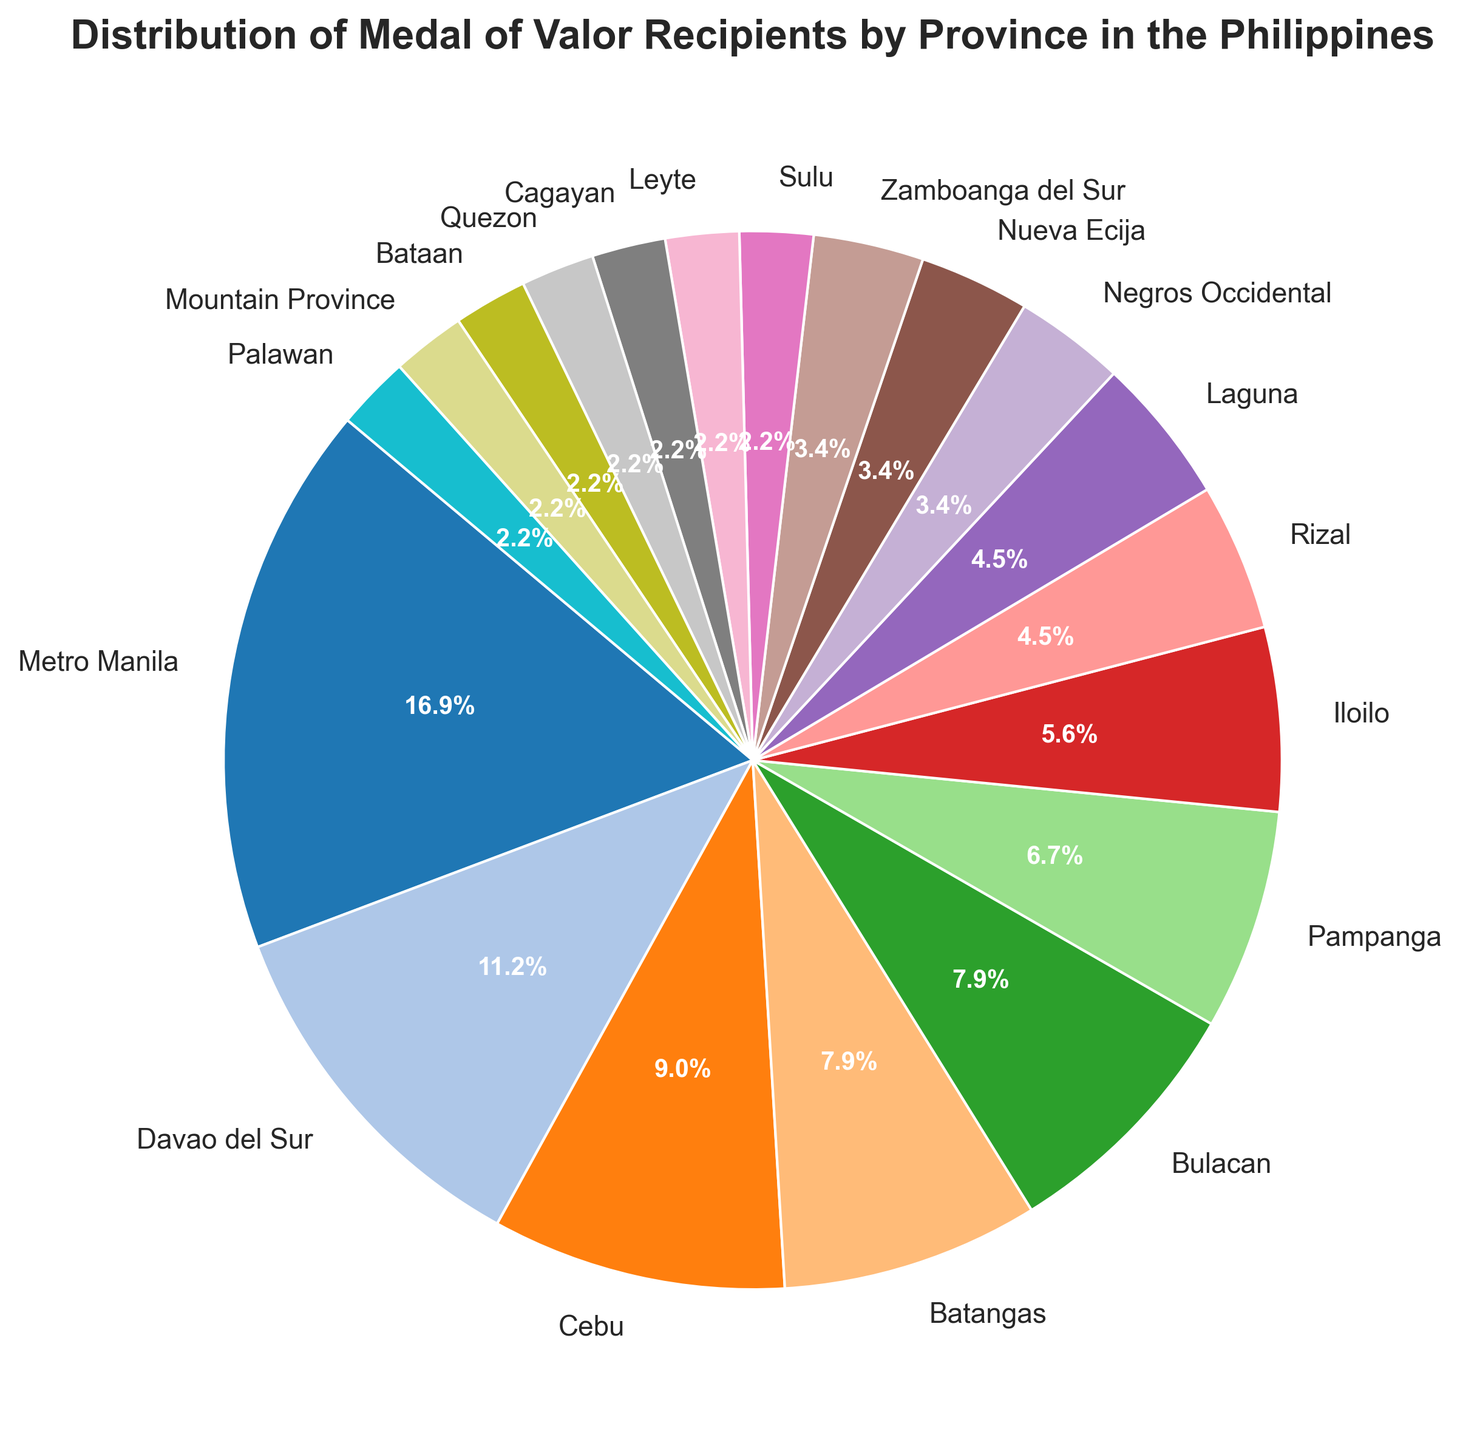Which province has the highest number of Medal of Valor recipients? Metro Manila occupies the largest section of the pie chart, indicating it has the most recipients.
Answer: Metro Manila What percentage of Medal of Valor recipients come from outside Metro Manila? Metro Manila accounts for 15 recipients out of a total of 91 (15 from Metro Manila + 76 from other provinces), therefore the percentage from other provinces is ((76/91) * 100)%.
Answer: Approximately 83.5% Which provinces have the same number of recipients? By examining the chart segments and their labels, Batangas and Bulacan have the same number of recipients, as do Laguna and Rizal.
Answer: Batangas and Bulacan, Laguna and Rizal How many provinces have fewer than 5 recipients? To determine this, identify the slices representing those provinces with fewer than 5 recipients, such as Negros Occidental, Nueva Ecija, Zamboanga del Sur, and others with even fewer. Count these slices.
Answer: 12 provinces What is the combined percentage of recipients from Cebu, Batangas, and Bulacan? Add the recipients from these provinces (8 from Cebu, 7 from Batangas, 7 from Bulacan). The combined total is 22 out of 91. The percentage is (22/91) * 100.
Answer: Approximately 24.2% How does the number of recipients in Pampanga compare to those in Iloilo? Look at the pie chart slices for these provinces. Pampanga has 6 recipients, and Iloilo has 5 recipients. Therefore, Pampanga has more recipients than Iloilo.
Answer: Pampanga has more recipients Which province contributed the smallest number of recipients? The slices representing Sulu, Leyte, Cagayan, Quezon, Bataan, Mountain Province, and Palawan are the smallest in the pie chart, each having 2 recipients.
Answer: Several provinces (Sulu, Leyte, Cagayan, Quezon, Bataan, Mountain Province, Palawan) What proportion of the total recipients do the top three provinces account for? Metro Manila, Davao del Sur, and Cebu are the top three. Their numbers are 15, 10, and 8 respectively, making a total of 33 recipients. The proportion is (33/91).
Answer: Approximately 36.3% If the number of recipients from Quezon doubled, what percentage would it be of the total? Double the recipients from Quezon makes it 4. The new total recipients is 93. The new percentage for Quezon is (4/93) * 100.
Answer: Approximately 4.3% Which provinces have an equal number of recipients, making them visually indistinguishable in size on the chart? Identify the chart sections that appear to have equal size. This includes Batangas and Bulacan, and also regions like Sulu, Leyte, Cagayan, Quezon, Bataan, Mountain Province, Palawan.
Answer: Batangas and Bulacan, Sulu, Leyte, Cagayan, Quezon, Bataan, Mountain Province, Palawan 